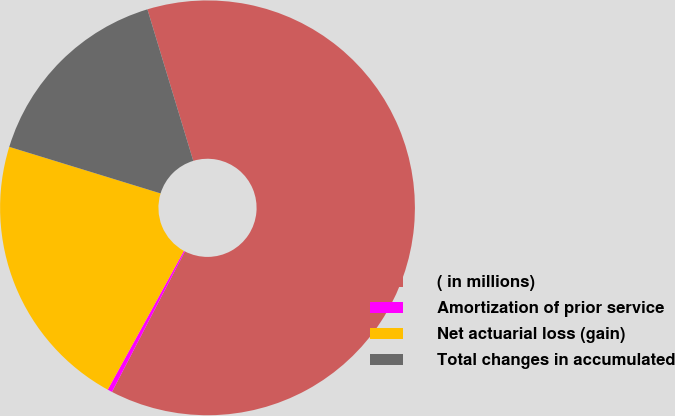Convert chart. <chart><loc_0><loc_0><loc_500><loc_500><pie_chart><fcel>( in millions)<fcel>Amortization of prior service<fcel>Net actuarial loss (gain)<fcel>Total changes in accumulated<nl><fcel>62.29%<fcel>0.37%<fcel>21.76%<fcel>15.57%<nl></chart> 